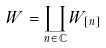Convert formula to latex. <formula><loc_0><loc_0><loc_500><loc_500>W = \coprod _ { n \in { \mathbb { C } } } W _ { [ n ] }</formula> 